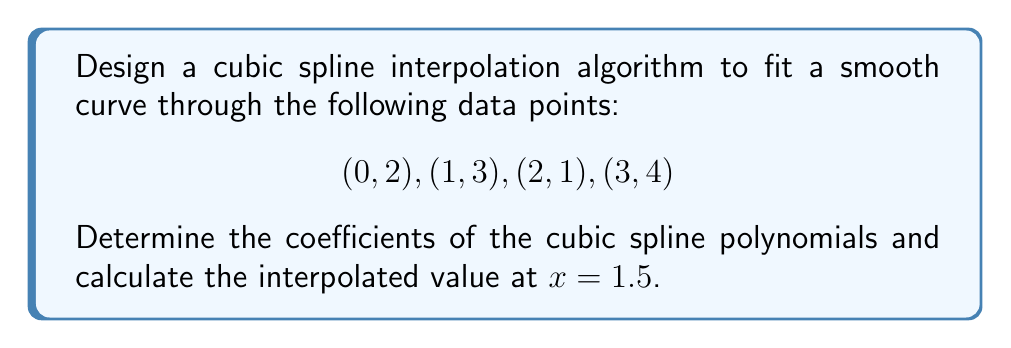What is the answer to this math problem? To design a cubic spline interpolation algorithm, we'll follow these steps:

1) For $n$ data points, we need $n-1$ cubic polynomials of the form:
   $$S_i(x) = a_i + b_i(x-x_i) + c_i(x-x_i)^2 + d_i(x-x_i)^3$$
   where $i = 1, 2, ..., n-1$

2) We have 4 data points, so we need 3 cubic polynomials.

3) Conditions for cubic spline:
   a) $S_i(x_i) = y_i$ and $S_i(x_{i+1}) = y_{i+1}$ (interpolation)
   b) $S'_i(x_{i+1}) = S'_{i+1}(x_{i+1})$ (first derivative continuity)
   c) $S''_i(x_{i+1}) = S''_{i+1}(x_{i+1})$ (second derivative continuity)
   d) $S''_1(x_1) = S''_n(x_n) = 0$ (natural spline condition)

4) From the interpolation condition:
   $$a_i = y_i$$
   $$a_i + b_i(x_{i+1}-x_i) + c_i(x_{i+1}-x_i)^2 + d_i(x_{i+1}-x_i)^3 = y_{i+1}$$

5) From the first derivative continuity:
   $$b_i + 2c_i(x_{i+1}-x_i) + 3d_i(x_{i+1}-x_i)^2 = b_{i+1}$$

6) From the second derivative continuity:
   $$2c_i + 6d_i(x_{i+1}-x_i) = 2c_{i+1}$$

7) Solving this system of equations leads to a tridiagonal system for $c_i$:
   $$\frac{x_{i+1}-x_i}{6}c_i + \frac{x_{i+1}-x_{i-1}}{3}c_{i+1} + \frac{x_i-x_{i-1}}{6}c_{i+2} = \frac{y_{i+2}-y_{i+1}}{x_{i+2}-x_{i+1}} - \frac{y_{i+1}-y_i}{x_{i+1}-x_i}$$

8) Solving this system with the natural spline conditions gives us $c_i$.

9) We can then find $b_i$ and $d_i$ using:
   $$b_i = \frac{y_{i+1}-y_i}{x_{i+1}-x_i} - \frac{(x_{i+1}-x_i)(2c_i+c_{i+1})}{3}$$
   $$d_i = \frac{c_{i+1}-c_i}{3(x_{i+1}-x_i)}$$

10) Solving this system for our data points gives:

    For $S_1(x)$ on $[0,1]$:
    $a_1 = 2, b_1 = 0.5, c_1 = 0.5, d_1 = -0.5$

    For $S_2(x)$ on $[1,2]$:
    $a_2 = 3, b_2 = -0.5, c_2 = -1, d_2 = 0.5$

    For $S_3(x)$ on $[2,3]$:
    $a_3 = 1, b_3 = 2.5, c_3 = 0.5, d_3 = -0.5$

11) To interpolate at $x = 1.5$, we use $S_2(x)$:
    $$S_2(1.5) = 3 + (-0.5)(0.5) + (-1)(0.5)^2 + (0.5)(0.5)^3 = 2.3125$$
Answer: The coefficients of the cubic spline polynomials are:

$S_1(x) = 2 + 0.5(x-0) + 0.5(x-0)^2 - 0.5(x-0)^3$
$S_2(x) = 3 - 0.5(x-1) - (x-1)^2 + 0.5(x-1)^3$
$S_3(x) = 1 + 2.5(x-2) + 0.5(x-2)^2 - 0.5(x-2)^3$

The interpolated value at $x = 1.5$ is 2.3125. 